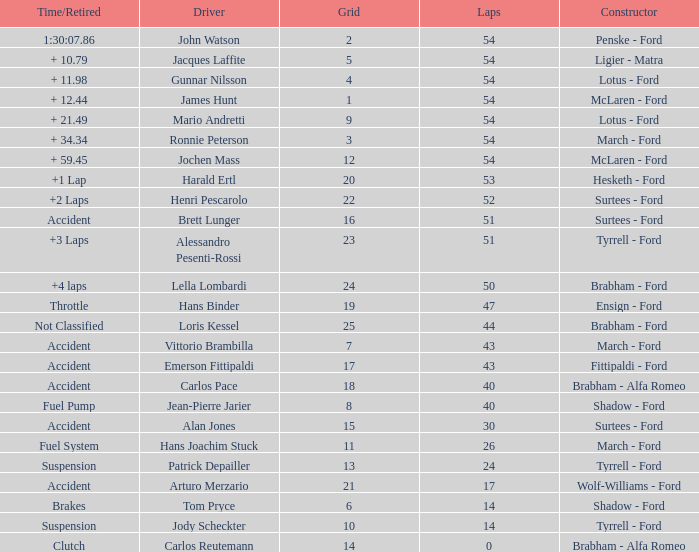How many laps did Emerson Fittipaldi do on a grid larger than 14, and when was the Time/Retired of accident? 1.0. 